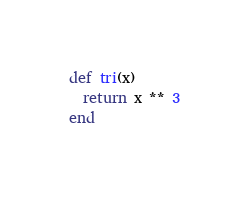<code> <loc_0><loc_0><loc_500><loc_500><_Ruby_>def tri(x)
  return x ** 3
end</code> 